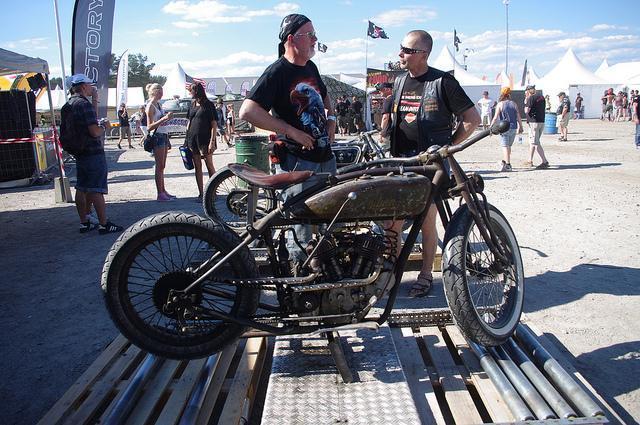What material are the pipes which are holding up the old bike?
Answer the question by selecting the correct answer among the 4 following choices.
Options: Concrete, wood, sand, plastic. Wood. 